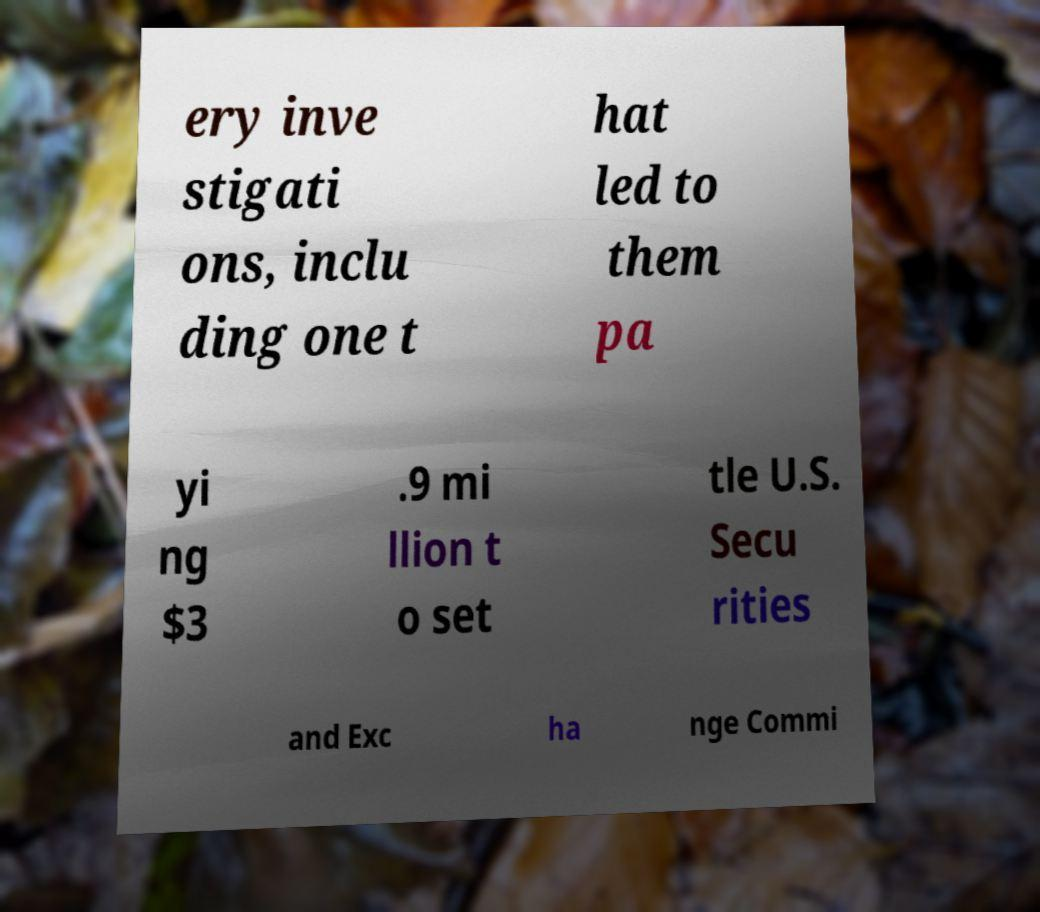Could you extract and type out the text from this image? ery inve stigati ons, inclu ding one t hat led to them pa yi ng $3 .9 mi llion t o set tle U.S. Secu rities and Exc ha nge Commi 